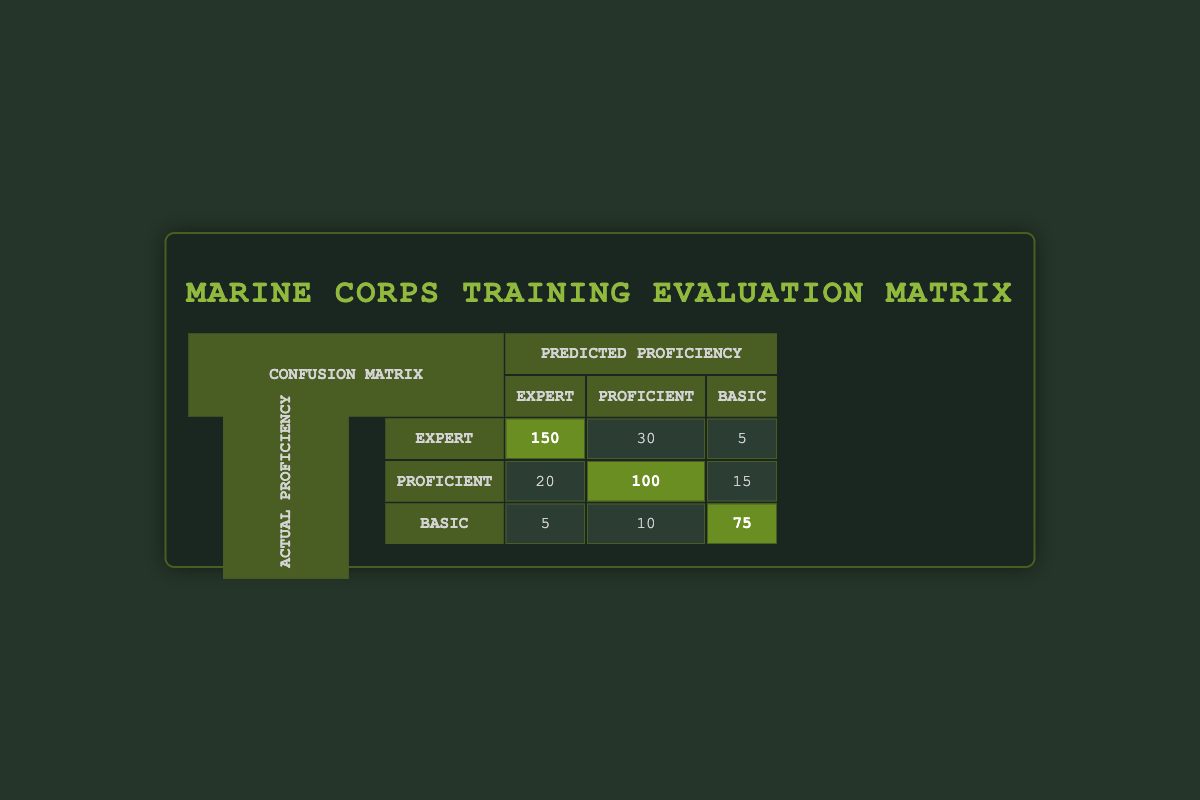What is the count of Marines predicted to be "Expert" who were actually "Expert"? The table shows a specific cell corresponding to actual proficiency "Expert" and predicted proficiency "Expert" with a count of 150.
Answer: 150 How many Marines were predicted to be "Basic" but were actually "Proficient"? In the table, for actual proficiency "Proficient" and predicted proficiency "Basic," the count is 15.
Answer: 15 What is the total number of Marines who were actually "Basic"? To find this, sum the counts in the row for actual proficiency "Basic": 5 (Expert) + 10 (Proficient) + 75 (Basic) = 90.
Answer: 90 Is it true that more Marines were predicted as "Proficient" than "Expert"? In the table, Marines predicted as "Proficient" is 100 (actual Proficient) + 10 (actual Basic) = 110, while those predicted as "Expert" is 150 (actual Expert) + 20 (actual Proficient) + 5 (actual Basic) = 175. Thus, it is false that more were predicted as "Proficient" than "Expert."
Answer: No How many Marines were misclassified as "Proficient" when they were actually "Expert"? For actual proficiency "Expert" and predicted proficiency "Proficient," the count is 30, indicating misclassification of Marines who were actually Expert but predicted Proficient.
Answer: 30 What is the average number of Marines predicted to be "Basic"? To find the average, sum the counts of predicted "Basic," which are 75 (actual Basic) + 5 (actual Expert) + 15 (actual Proficient) = 95. Then divide by 3 (the number of categories): 95 / 3 = 31.67.
Answer: 31.67 How many Marines correctly identified as "Expert" did not fall into the other proficiency categories? The only category for Marines that were correctly identified is the count of 150 in the "Expert" row and "Expert" column. Other counts in the same row denote misclassifications. Therefore, no additional counts contribute here.
Answer: 150 What is the total count of Marines predicted correctly across all proficiency levels? Sum all the cells that are in the diagonal of the matrix where actual equals predicted: 150 (Expert) + 100 (Proficient) + 75 (Basic) = 325.
Answer: 325 How many Marines anticipated to be "Expert" were incorrectly predicted as "Basic"? The count for Marines with actual proficiency "Expert" but predicted as "Basic" is 5 according to the table.
Answer: 5 